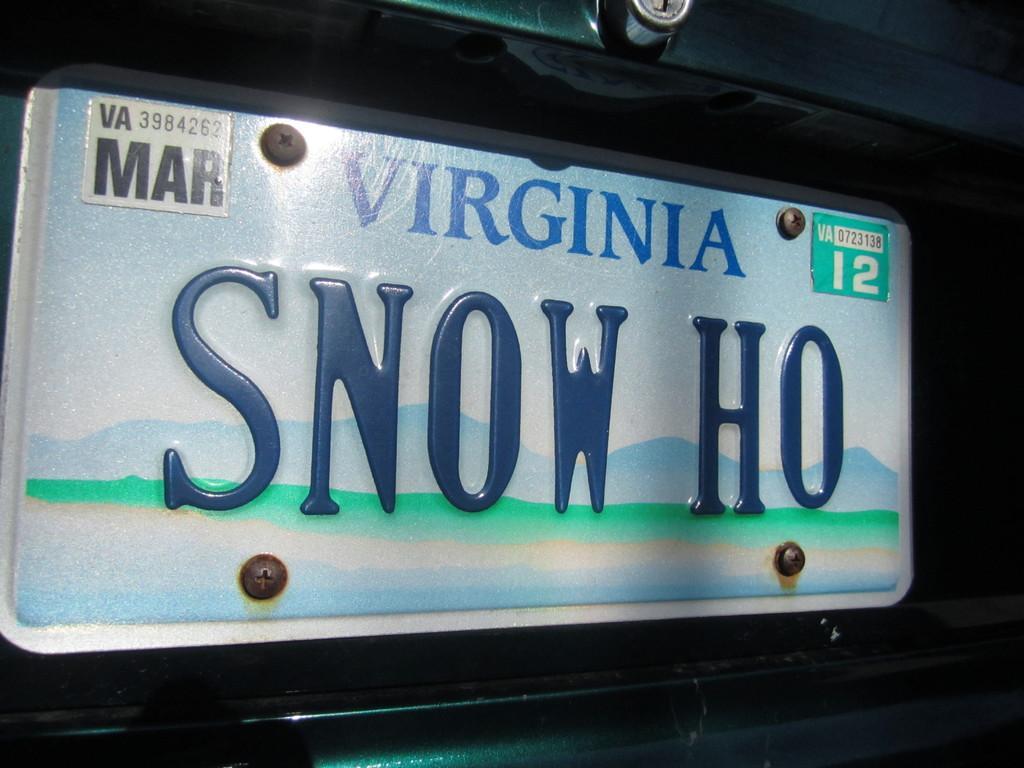Describe this image in one or two sentences. In this image we can see a board with the text and also numbers. 